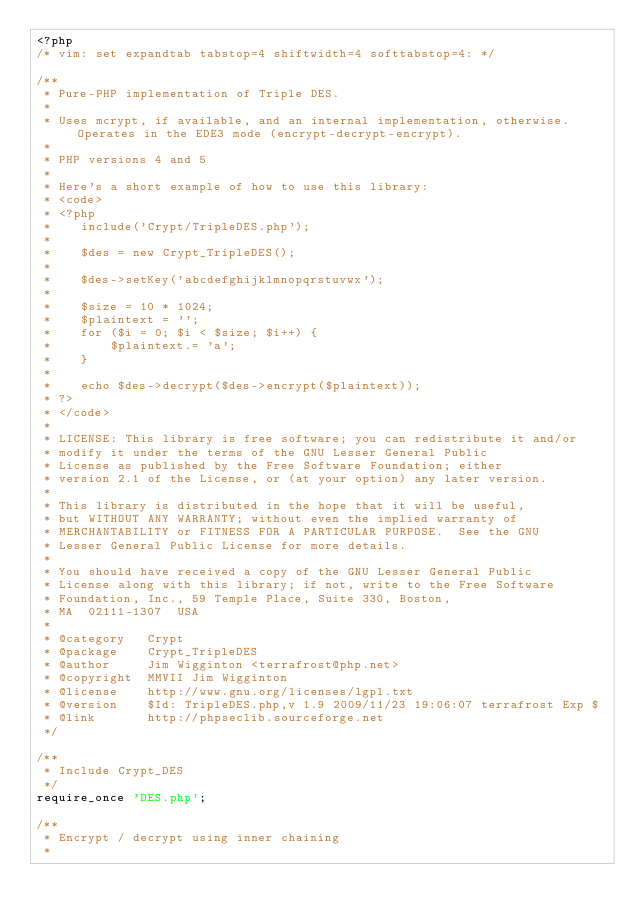<code> <loc_0><loc_0><loc_500><loc_500><_PHP_><?php
/* vim: set expandtab tabstop=4 shiftwidth=4 softtabstop=4: */

/**
 * Pure-PHP implementation of Triple DES.
 *
 * Uses mcrypt, if available, and an internal implementation, otherwise.  Operates in the EDE3 mode (encrypt-decrypt-encrypt).
 *
 * PHP versions 4 and 5
 *
 * Here's a short example of how to use this library:
 * <code>
 * <?php
 *    include('Crypt/TripleDES.php');
 *
 *    $des = new Crypt_TripleDES();
 *
 *    $des->setKey('abcdefghijklmnopqrstuvwx');
 *
 *    $size = 10 * 1024;
 *    $plaintext = '';
 *    for ($i = 0; $i < $size; $i++) {
 *        $plaintext.= 'a';
 *    }
 *
 *    echo $des->decrypt($des->encrypt($plaintext));
 * ?>
 * </code>
 *
 * LICENSE: This library is free software; you can redistribute it and/or
 * modify it under the terms of the GNU Lesser General Public
 * License as published by the Free Software Foundation; either
 * version 2.1 of the License, or (at your option) any later version.
 *
 * This library is distributed in the hope that it will be useful,
 * but WITHOUT ANY WARRANTY; without even the implied warranty of
 * MERCHANTABILITY or FITNESS FOR A PARTICULAR PURPOSE.  See the GNU
 * Lesser General Public License for more details.
 *
 * You should have received a copy of the GNU Lesser General Public
 * License along with this library; if not, write to the Free Software
 * Foundation, Inc., 59 Temple Place, Suite 330, Boston,
 * MA  02111-1307  USA
 *
 * @category   Crypt
 * @package    Crypt_TripleDES
 * @author     Jim Wigginton <terrafrost@php.net>
 * @copyright  MMVII Jim Wigginton
 * @license    http://www.gnu.org/licenses/lgpl.txt
 * @version    $Id: TripleDES.php,v 1.9 2009/11/23 19:06:07 terrafrost Exp $
 * @link       http://phpseclib.sourceforge.net
 */

/**
 * Include Crypt_DES
 */
require_once 'DES.php';

/**
 * Encrypt / decrypt using inner chaining
 *</code> 